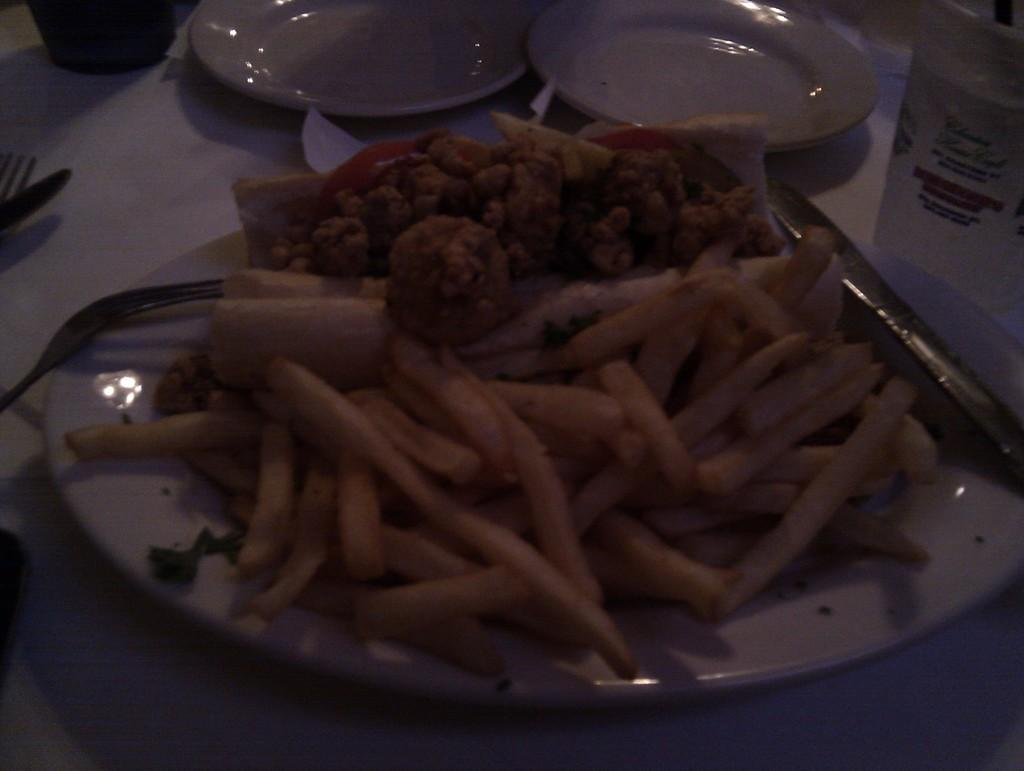What piece of furniture is present in the image? There is a table in the image. What is placed on the table? There is a plate on the table. What is on the plate? There is a food item on the plate. What utensil is visible in the image? There is a spoon in the image. Can you describe any other objects in the image? There are some objects in the image. Where is the chalk stored in the image? There is no chalk present in the image. What type of receipt can be seen on the table in the image? There is no receipt visible in the image. 